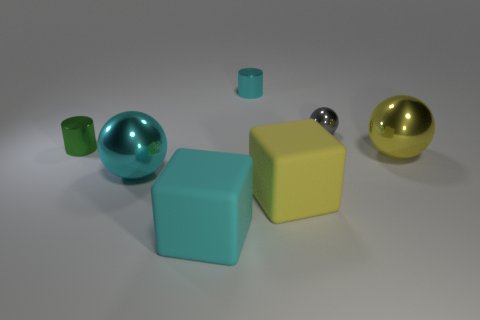The big metallic thing to the left of the large yellow thing behind the yellow block that is right of the green metallic thing is what shape?
Your answer should be very brief. Sphere. There is a small cylinder behind the object on the left side of the metallic thing that is in front of the big yellow shiny ball; what is its color?
Offer a terse response. Cyan. Are the yellow thing that is to the right of the yellow cube and the cyan thing in front of the large cyan sphere made of the same material?
Give a very brief answer. No. What is the shape of the cyan metal object that is behind the large cyan metal object?
Ensure brevity in your answer.  Cylinder. How many things are either cylinders or big metallic things that are on the right side of the cyan metal cylinder?
Ensure brevity in your answer.  3. Does the small green thing have the same material as the small gray object?
Ensure brevity in your answer.  Yes. Are there an equal number of cylinders that are to the right of the big cyan metal object and cyan cylinders that are on the left side of the big cyan rubber object?
Keep it short and to the point. No. How many tiny cyan cylinders are left of the tiny green object?
Keep it short and to the point. 0. How many objects are tiny purple rubber spheres or cyan rubber blocks?
Your response must be concise. 1. What number of purple shiny spheres are the same size as the yellow matte thing?
Keep it short and to the point. 0. 